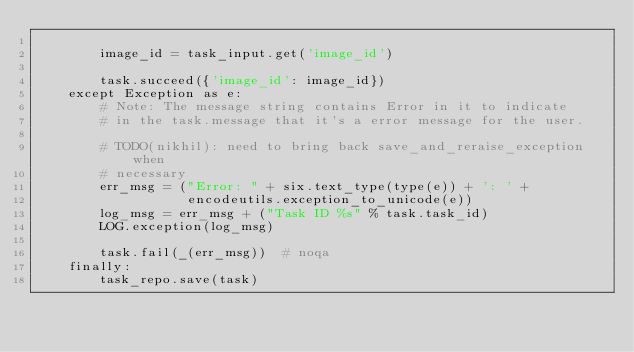<code> <loc_0><loc_0><loc_500><loc_500><_Python_>
        image_id = task_input.get('image_id')

        task.succeed({'image_id': image_id})
    except Exception as e:
        # Note: The message string contains Error in it to indicate
        # in the task.message that it's a error message for the user.

        # TODO(nikhil): need to bring back save_and_reraise_exception when
        # necessary
        err_msg = ("Error: " + six.text_type(type(e)) + ': ' +
                   encodeutils.exception_to_unicode(e))
        log_msg = err_msg + ("Task ID %s" % task.task_id)
        LOG.exception(log_msg)

        task.fail(_(err_msg))  # noqa
    finally:
        task_repo.save(task)

</code> 